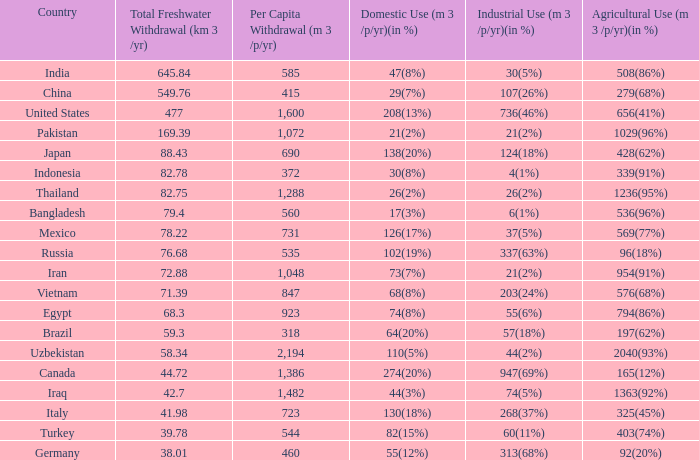75, and agricultural usage (m3/p/yr)(in %) is 1363(92%)? 74(5%). 